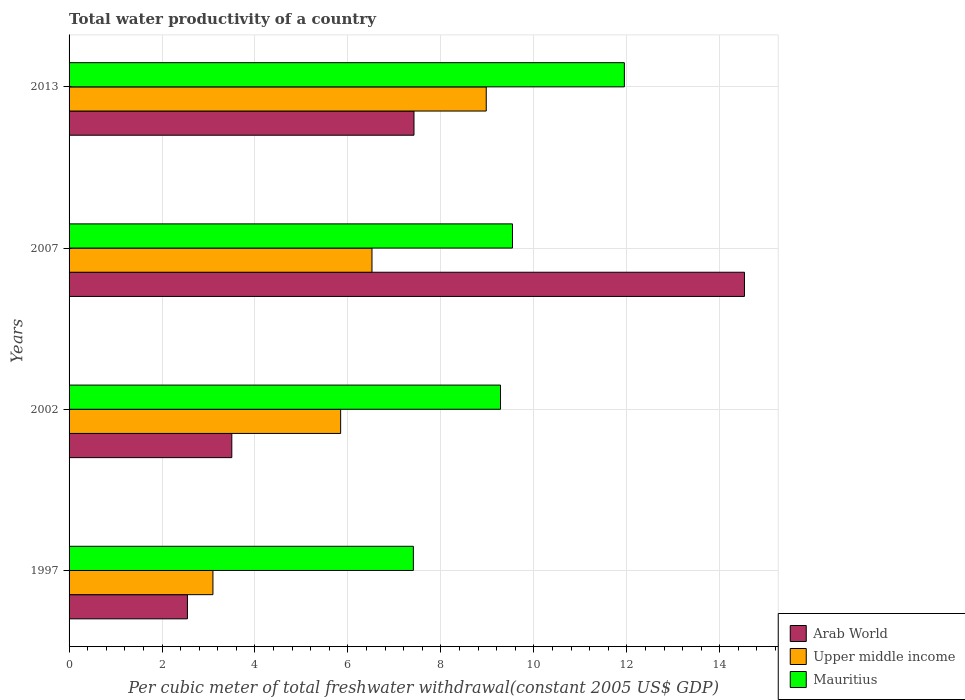How many different coloured bars are there?
Make the answer very short. 3. How many groups of bars are there?
Ensure brevity in your answer.  4. Are the number of bars per tick equal to the number of legend labels?
Provide a succinct answer. Yes. How many bars are there on the 3rd tick from the top?
Provide a succinct answer. 3. What is the label of the 3rd group of bars from the top?
Provide a succinct answer. 2002. What is the total water productivity in Upper middle income in 2013?
Your answer should be very brief. 8.98. Across all years, what is the maximum total water productivity in Mauritius?
Provide a succinct answer. 11.95. Across all years, what is the minimum total water productivity in Upper middle income?
Offer a very short reply. 3.1. In which year was the total water productivity in Upper middle income maximum?
Keep it short and to the point. 2013. What is the total total water productivity in Mauritius in the graph?
Ensure brevity in your answer.  38.18. What is the difference between the total water productivity in Upper middle income in 1997 and that in 2002?
Make the answer very short. -2.75. What is the difference between the total water productivity in Arab World in 2013 and the total water productivity in Mauritius in 2002?
Keep it short and to the point. -1.86. What is the average total water productivity in Arab World per year?
Keep it short and to the point. 7. In the year 2013, what is the difference between the total water productivity in Mauritius and total water productivity in Upper middle income?
Offer a very short reply. 2.97. What is the ratio of the total water productivity in Mauritius in 1997 to that in 2013?
Make the answer very short. 0.62. Is the difference between the total water productivity in Mauritius in 1997 and 2002 greater than the difference between the total water productivity in Upper middle income in 1997 and 2002?
Ensure brevity in your answer.  Yes. What is the difference between the highest and the second highest total water productivity in Upper middle income?
Offer a terse response. 2.46. What is the difference between the highest and the lowest total water productivity in Arab World?
Your response must be concise. 11.98. What does the 3rd bar from the top in 2002 represents?
Provide a short and direct response. Arab World. What does the 1st bar from the bottom in 1997 represents?
Offer a terse response. Arab World. How many bars are there?
Your response must be concise. 12. How many years are there in the graph?
Provide a succinct answer. 4. Are the values on the major ticks of X-axis written in scientific E-notation?
Your response must be concise. No. How many legend labels are there?
Give a very brief answer. 3. How are the legend labels stacked?
Your response must be concise. Vertical. What is the title of the graph?
Keep it short and to the point. Total water productivity of a country. Does "Solomon Islands" appear as one of the legend labels in the graph?
Keep it short and to the point. No. What is the label or title of the X-axis?
Provide a short and direct response. Per cubic meter of total freshwater withdrawal(constant 2005 US$ GDP). What is the Per cubic meter of total freshwater withdrawal(constant 2005 US$ GDP) of Arab World in 1997?
Provide a short and direct response. 2.55. What is the Per cubic meter of total freshwater withdrawal(constant 2005 US$ GDP) of Upper middle income in 1997?
Your answer should be compact. 3.1. What is the Per cubic meter of total freshwater withdrawal(constant 2005 US$ GDP) in Mauritius in 1997?
Ensure brevity in your answer.  7.41. What is the Per cubic meter of total freshwater withdrawal(constant 2005 US$ GDP) of Arab World in 2002?
Give a very brief answer. 3.5. What is the Per cubic meter of total freshwater withdrawal(constant 2005 US$ GDP) in Upper middle income in 2002?
Your response must be concise. 5.84. What is the Per cubic meter of total freshwater withdrawal(constant 2005 US$ GDP) of Mauritius in 2002?
Provide a short and direct response. 9.28. What is the Per cubic meter of total freshwater withdrawal(constant 2005 US$ GDP) in Arab World in 2007?
Offer a very short reply. 14.53. What is the Per cubic meter of total freshwater withdrawal(constant 2005 US$ GDP) in Upper middle income in 2007?
Give a very brief answer. 6.52. What is the Per cubic meter of total freshwater withdrawal(constant 2005 US$ GDP) in Mauritius in 2007?
Ensure brevity in your answer.  9.54. What is the Per cubic meter of total freshwater withdrawal(constant 2005 US$ GDP) in Arab World in 2013?
Ensure brevity in your answer.  7.42. What is the Per cubic meter of total freshwater withdrawal(constant 2005 US$ GDP) of Upper middle income in 2013?
Your answer should be compact. 8.98. What is the Per cubic meter of total freshwater withdrawal(constant 2005 US$ GDP) of Mauritius in 2013?
Keep it short and to the point. 11.95. Across all years, what is the maximum Per cubic meter of total freshwater withdrawal(constant 2005 US$ GDP) of Arab World?
Make the answer very short. 14.53. Across all years, what is the maximum Per cubic meter of total freshwater withdrawal(constant 2005 US$ GDP) in Upper middle income?
Offer a terse response. 8.98. Across all years, what is the maximum Per cubic meter of total freshwater withdrawal(constant 2005 US$ GDP) in Mauritius?
Offer a very short reply. 11.95. Across all years, what is the minimum Per cubic meter of total freshwater withdrawal(constant 2005 US$ GDP) of Arab World?
Offer a very short reply. 2.55. Across all years, what is the minimum Per cubic meter of total freshwater withdrawal(constant 2005 US$ GDP) in Upper middle income?
Give a very brief answer. 3.1. Across all years, what is the minimum Per cubic meter of total freshwater withdrawal(constant 2005 US$ GDP) in Mauritius?
Keep it short and to the point. 7.41. What is the total Per cubic meter of total freshwater withdrawal(constant 2005 US$ GDP) of Arab World in the graph?
Ensure brevity in your answer.  28. What is the total Per cubic meter of total freshwater withdrawal(constant 2005 US$ GDP) of Upper middle income in the graph?
Offer a very short reply. 24.43. What is the total Per cubic meter of total freshwater withdrawal(constant 2005 US$ GDP) of Mauritius in the graph?
Provide a short and direct response. 38.18. What is the difference between the Per cubic meter of total freshwater withdrawal(constant 2005 US$ GDP) in Arab World in 1997 and that in 2002?
Your answer should be compact. -0.95. What is the difference between the Per cubic meter of total freshwater withdrawal(constant 2005 US$ GDP) in Upper middle income in 1997 and that in 2002?
Your answer should be compact. -2.75. What is the difference between the Per cubic meter of total freshwater withdrawal(constant 2005 US$ GDP) of Mauritius in 1997 and that in 2002?
Provide a succinct answer. -1.87. What is the difference between the Per cubic meter of total freshwater withdrawal(constant 2005 US$ GDP) of Arab World in 1997 and that in 2007?
Offer a terse response. -11.98. What is the difference between the Per cubic meter of total freshwater withdrawal(constant 2005 US$ GDP) of Upper middle income in 1997 and that in 2007?
Provide a succinct answer. -3.42. What is the difference between the Per cubic meter of total freshwater withdrawal(constant 2005 US$ GDP) in Mauritius in 1997 and that in 2007?
Your answer should be compact. -2.13. What is the difference between the Per cubic meter of total freshwater withdrawal(constant 2005 US$ GDP) of Arab World in 1997 and that in 2013?
Keep it short and to the point. -4.87. What is the difference between the Per cubic meter of total freshwater withdrawal(constant 2005 US$ GDP) of Upper middle income in 1997 and that in 2013?
Your response must be concise. -5.88. What is the difference between the Per cubic meter of total freshwater withdrawal(constant 2005 US$ GDP) in Mauritius in 1997 and that in 2013?
Provide a succinct answer. -4.54. What is the difference between the Per cubic meter of total freshwater withdrawal(constant 2005 US$ GDP) in Arab World in 2002 and that in 2007?
Ensure brevity in your answer.  -11.03. What is the difference between the Per cubic meter of total freshwater withdrawal(constant 2005 US$ GDP) of Upper middle income in 2002 and that in 2007?
Provide a succinct answer. -0.67. What is the difference between the Per cubic meter of total freshwater withdrawal(constant 2005 US$ GDP) of Mauritius in 2002 and that in 2007?
Provide a short and direct response. -0.26. What is the difference between the Per cubic meter of total freshwater withdrawal(constant 2005 US$ GDP) of Arab World in 2002 and that in 2013?
Ensure brevity in your answer.  -3.92. What is the difference between the Per cubic meter of total freshwater withdrawal(constant 2005 US$ GDP) of Upper middle income in 2002 and that in 2013?
Your answer should be very brief. -3.13. What is the difference between the Per cubic meter of total freshwater withdrawal(constant 2005 US$ GDP) of Mauritius in 2002 and that in 2013?
Your answer should be very brief. -2.66. What is the difference between the Per cubic meter of total freshwater withdrawal(constant 2005 US$ GDP) of Arab World in 2007 and that in 2013?
Keep it short and to the point. 7.11. What is the difference between the Per cubic meter of total freshwater withdrawal(constant 2005 US$ GDP) in Upper middle income in 2007 and that in 2013?
Provide a short and direct response. -2.46. What is the difference between the Per cubic meter of total freshwater withdrawal(constant 2005 US$ GDP) of Mauritius in 2007 and that in 2013?
Ensure brevity in your answer.  -2.41. What is the difference between the Per cubic meter of total freshwater withdrawal(constant 2005 US$ GDP) in Arab World in 1997 and the Per cubic meter of total freshwater withdrawal(constant 2005 US$ GDP) in Upper middle income in 2002?
Your answer should be compact. -3.3. What is the difference between the Per cubic meter of total freshwater withdrawal(constant 2005 US$ GDP) of Arab World in 1997 and the Per cubic meter of total freshwater withdrawal(constant 2005 US$ GDP) of Mauritius in 2002?
Your answer should be compact. -6.74. What is the difference between the Per cubic meter of total freshwater withdrawal(constant 2005 US$ GDP) of Upper middle income in 1997 and the Per cubic meter of total freshwater withdrawal(constant 2005 US$ GDP) of Mauritius in 2002?
Provide a succinct answer. -6.19. What is the difference between the Per cubic meter of total freshwater withdrawal(constant 2005 US$ GDP) of Arab World in 1997 and the Per cubic meter of total freshwater withdrawal(constant 2005 US$ GDP) of Upper middle income in 2007?
Your answer should be very brief. -3.97. What is the difference between the Per cubic meter of total freshwater withdrawal(constant 2005 US$ GDP) of Arab World in 1997 and the Per cubic meter of total freshwater withdrawal(constant 2005 US$ GDP) of Mauritius in 2007?
Your response must be concise. -6.99. What is the difference between the Per cubic meter of total freshwater withdrawal(constant 2005 US$ GDP) of Upper middle income in 1997 and the Per cubic meter of total freshwater withdrawal(constant 2005 US$ GDP) of Mauritius in 2007?
Provide a succinct answer. -6.44. What is the difference between the Per cubic meter of total freshwater withdrawal(constant 2005 US$ GDP) of Arab World in 1997 and the Per cubic meter of total freshwater withdrawal(constant 2005 US$ GDP) of Upper middle income in 2013?
Offer a very short reply. -6.43. What is the difference between the Per cubic meter of total freshwater withdrawal(constant 2005 US$ GDP) in Arab World in 1997 and the Per cubic meter of total freshwater withdrawal(constant 2005 US$ GDP) in Mauritius in 2013?
Provide a succinct answer. -9.4. What is the difference between the Per cubic meter of total freshwater withdrawal(constant 2005 US$ GDP) in Upper middle income in 1997 and the Per cubic meter of total freshwater withdrawal(constant 2005 US$ GDP) in Mauritius in 2013?
Provide a short and direct response. -8.85. What is the difference between the Per cubic meter of total freshwater withdrawal(constant 2005 US$ GDP) in Arab World in 2002 and the Per cubic meter of total freshwater withdrawal(constant 2005 US$ GDP) in Upper middle income in 2007?
Provide a short and direct response. -3.02. What is the difference between the Per cubic meter of total freshwater withdrawal(constant 2005 US$ GDP) of Arab World in 2002 and the Per cubic meter of total freshwater withdrawal(constant 2005 US$ GDP) of Mauritius in 2007?
Provide a short and direct response. -6.04. What is the difference between the Per cubic meter of total freshwater withdrawal(constant 2005 US$ GDP) in Upper middle income in 2002 and the Per cubic meter of total freshwater withdrawal(constant 2005 US$ GDP) in Mauritius in 2007?
Your answer should be compact. -3.7. What is the difference between the Per cubic meter of total freshwater withdrawal(constant 2005 US$ GDP) in Arab World in 2002 and the Per cubic meter of total freshwater withdrawal(constant 2005 US$ GDP) in Upper middle income in 2013?
Offer a very short reply. -5.47. What is the difference between the Per cubic meter of total freshwater withdrawal(constant 2005 US$ GDP) in Arab World in 2002 and the Per cubic meter of total freshwater withdrawal(constant 2005 US$ GDP) in Mauritius in 2013?
Keep it short and to the point. -8.45. What is the difference between the Per cubic meter of total freshwater withdrawal(constant 2005 US$ GDP) of Upper middle income in 2002 and the Per cubic meter of total freshwater withdrawal(constant 2005 US$ GDP) of Mauritius in 2013?
Your answer should be compact. -6.1. What is the difference between the Per cubic meter of total freshwater withdrawal(constant 2005 US$ GDP) in Arab World in 2007 and the Per cubic meter of total freshwater withdrawal(constant 2005 US$ GDP) in Upper middle income in 2013?
Your answer should be compact. 5.56. What is the difference between the Per cubic meter of total freshwater withdrawal(constant 2005 US$ GDP) in Arab World in 2007 and the Per cubic meter of total freshwater withdrawal(constant 2005 US$ GDP) in Mauritius in 2013?
Offer a very short reply. 2.58. What is the difference between the Per cubic meter of total freshwater withdrawal(constant 2005 US$ GDP) of Upper middle income in 2007 and the Per cubic meter of total freshwater withdrawal(constant 2005 US$ GDP) of Mauritius in 2013?
Your response must be concise. -5.43. What is the average Per cubic meter of total freshwater withdrawal(constant 2005 US$ GDP) of Upper middle income per year?
Provide a succinct answer. 6.11. What is the average Per cubic meter of total freshwater withdrawal(constant 2005 US$ GDP) in Mauritius per year?
Your answer should be compact. 9.54. In the year 1997, what is the difference between the Per cubic meter of total freshwater withdrawal(constant 2005 US$ GDP) of Arab World and Per cubic meter of total freshwater withdrawal(constant 2005 US$ GDP) of Upper middle income?
Provide a succinct answer. -0.55. In the year 1997, what is the difference between the Per cubic meter of total freshwater withdrawal(constant 2005 US$ GDP) of Arab World and Per cubic meter of total freshwater withdrawal(constant 2005 US$ GDP) of Mauritius?
Give a very brief answer. -4.86. In the year 1997, what is the difference between the Per cubic meter of total freshwater withdrawal(constant 2005 US$ GDP) of Upper middle income and Per cubic meter of total freshwater withdrawal(constant 2005 US$ GDP) of Mauritius?
Make the answer very short. -4.31. In the year 2002, what is the difference between the Per cubic meter of total freshwater withdrawal(constant 2005 US$ GDP) of Arab World and Per cubic meter of total freshwater withdrawal(constant 2005 US$ GDP) of Upper middle income?
Your answer should be compact. -2.34. In the year 2002, what is the difference between the Per cubic meter of total freshwater withdrawal(constant 2005 US$ GDP) of Arab World and Per cubic meter of total freshwater withdrawal(constant 2005 US$ GDP) of Mauritius?
Offer a terse response. -5.78. In the year 2002, what is the difference between the Per cubic meter of total freshwater withdrawal(constant 2005 US$ GDP) in Upper middle income and Per cubic meter of total freshwater withdrawal(constant 2005 US$ GDP) in Mauritius?
Ensure brevity in your answer.  -3.44. In the year 2007, what is the difference between the Per cubic meter of total freshwater withdrawal(constant 2005 US$ GDP) of Arab World and Per cubic meter of total freshwater withdrawal(constant 2005 US$ GDP) of Upper middle income?
Offer a very short reply. 8.01. In the year 2007, what is the difference between the Per cubic meter of total freshwater withdrawal(constant 2005 US$ GDP) of Arab World and Per cubic meter of total freshwater withdrawal(constant 2005 US$ GDP) of Mauritius?
Your answer should be very brief. 4.99. In the year 2007, what is the difference between the Per cubic meter of total freshwater withdrawal(constant 2005 US$ GDP) of Upper middle income and Per cubic meter of total freshwater withdrawal(constant 2005 US$ GDP) of Mauritius?
Your answer should be very brief. -3.02. In the year 2013, what is the difference between the Per cubic meter of total freshwater withdrawal(constant 2005 US$ GDP) in Arab World and Per cubic meter of total freshwater withdrawal(constant 2005 US$ GDP) in Upper middle income?
Your answer should be very brief. -1.55. In the year 2013, what is the difference between the Per cubic meter of total freshwater withdrawal(constant 2005 US$ GDP) in Arab World and Per cubic meter of total freshwater withdrawal(constant 2005 US$ GDP) in Mauritius?
Offer a very short reply. -4.53. In the year 2013, what is the difference between the Per cubic meter of total freshwater withdrawal(constant 2005 US$ GDP) of Upper middle income and Per cubic meter of total freshwater withdrawal(constant 2005 US$ GDP) of Mauritius?
Your response must be concise. -2.97. What is the ratio of the Per cubic meter of total freshwater withdrawal(constant 2005 US$ GDP) in Arab World in 1997 to that in 2002?
Offer a very short reply. 0.73. What is the ratio of the Per cubic meter of total freshwater withdrawal(constant 2005 US$ GDP) of Upper middle income in 1997 to that in 2002?
Your answer should be compact. 0.53. What is the ratio of the Per cubic meter of total freshwater withdrawal(constant 2005 US$ GDP) of Mauritius in 1997 to that in 2002?
Provide a succinct answer. 0.8. What is the ratio of the Per cubic meter of total freshwater withdrawal(constant 2005 US$ GDP) of Arab World in 1997 to that in 2007?
Make the answer very short. 0.18. What is the ratio of the Per cubic meter of total freshwater withdrawal(constant 2005 US$ GDP) of Upper middle income in 1997 to that in 2007?
Ensure brevity in your answer.  0.47. What is the ratio of the Per cubic meter of total freshwater withdrawal(constant 2005 US$ GDP) of Mauritius in 1997 to that in 2007?
Provide a succinct answer. 0.78. What is the ratio of the Per cubic meter of total freshwater withdrawal(constant 2005 US$ GDP) in Arab World in 1997 to that in 2013?
Offer a terse response. 0.34. What is the ratio of the Per cubic meter of total freshwater withdrawal(constant 2005 US$ GDP) in Upper middle income in 1997 to that in 2013?
Give a very brief answer. 0.34. What is the ratio of the Per cubic meter of total freshwater withdrawal(constant 2005 US$ GDP) of Mauritius in 1997 to that in 2013?
Ensure brevity in your answer.  0.62. What is the ratio of the Per cubic meter of total freshwater withdrawal(constant 2005 US$ GDP) of Arab World in 2002 to that in 2007?
Offer a terse response. 0.24. What is the ratio of the Per cubic meter of total freshwater withdrawal(constant 2005 US$ GDP) in Upper middle income in 2002 to that in 2007?
Your response must be concise. 0.9. What is the ratio of the Per cubic meter of total freshwater withdrawal(constant 2005 US$ GDP) in Mauritius in 2002 to that in 2007?
Ensure brevity in your answer.  0.97. What is the ratio of the Per cubic meter of total freshwater withdrawal(constant 2005 US$ GDP) of Arab World in 2002 to that in 2013?
Provide a short and direct response. 0.47. What is the ratio of the Per cubic meter of total freshwater withdrawal(constant 2005 US$ GDP) in Upper middle income in 2002 to that in 2013?
Your answer should be compact. 0.65. What is the ratio of the Per cubic meter of total freshwater withdrawal(constant 2005 US$ GDP) of Mauritius in 2002 to that in 2013?
Keep it short and to the point. 0.78. What is the ratio of the Per cubic meter of total freshwater withdrawal(constant 2005 US$ GDP) of Arab World in 2007 to that in 2013?
Make the answer very short. 1.96. What is the ratio of the Per cubic meter of total freshwater withdrawal(constant 2005 US$ GDP) of Upper middle income in 2007 to that in 2013?
Provide a succinct answer. 0.73. What is the ratio of the Per cubic meter of total freshwater withdrawal(constant 2005 US$ GDP) in Mauritius in 2007 to that in 2013?
Offer a very short reply. 0.8. What is the difference between the highest and the second highest Per cubic meter of total freshwater withdrawal(constant 2005 US$ GDP) in Arab World?
Your response must be concise. 7.11. What is the difference between the highest and the second highest Per cubic meter of total freshwater withdrawal(constant 2005 US$ GDP) in Upper middle income?
Offer a terse response. 2.46. What is the difference between the highest and the second highest Per cubic meter of total freshwater withdrawal(constant 2005 US$ GDP) in Mauritius?
Your response must be concise. 2.41. What is the difference between the highest and the lowest Per cubic meter of total freshwater withdrawal(constant 2005 US$ GDP) in Arab World?
Keep it short and to the point. 11.98. What is the difference between the highest and the lowest Per cubic meter of total freshwater withdrawal(constant 2005 US$ GDP) in Upper middle income?
Give a very brief answer. 5.88. What is the difference between the highest and the lowest Per cubic meter of total freshwater withdrawal(constant 2005 US$ GDP) of Mauritius?
Your answer should be compact. 4.54. 